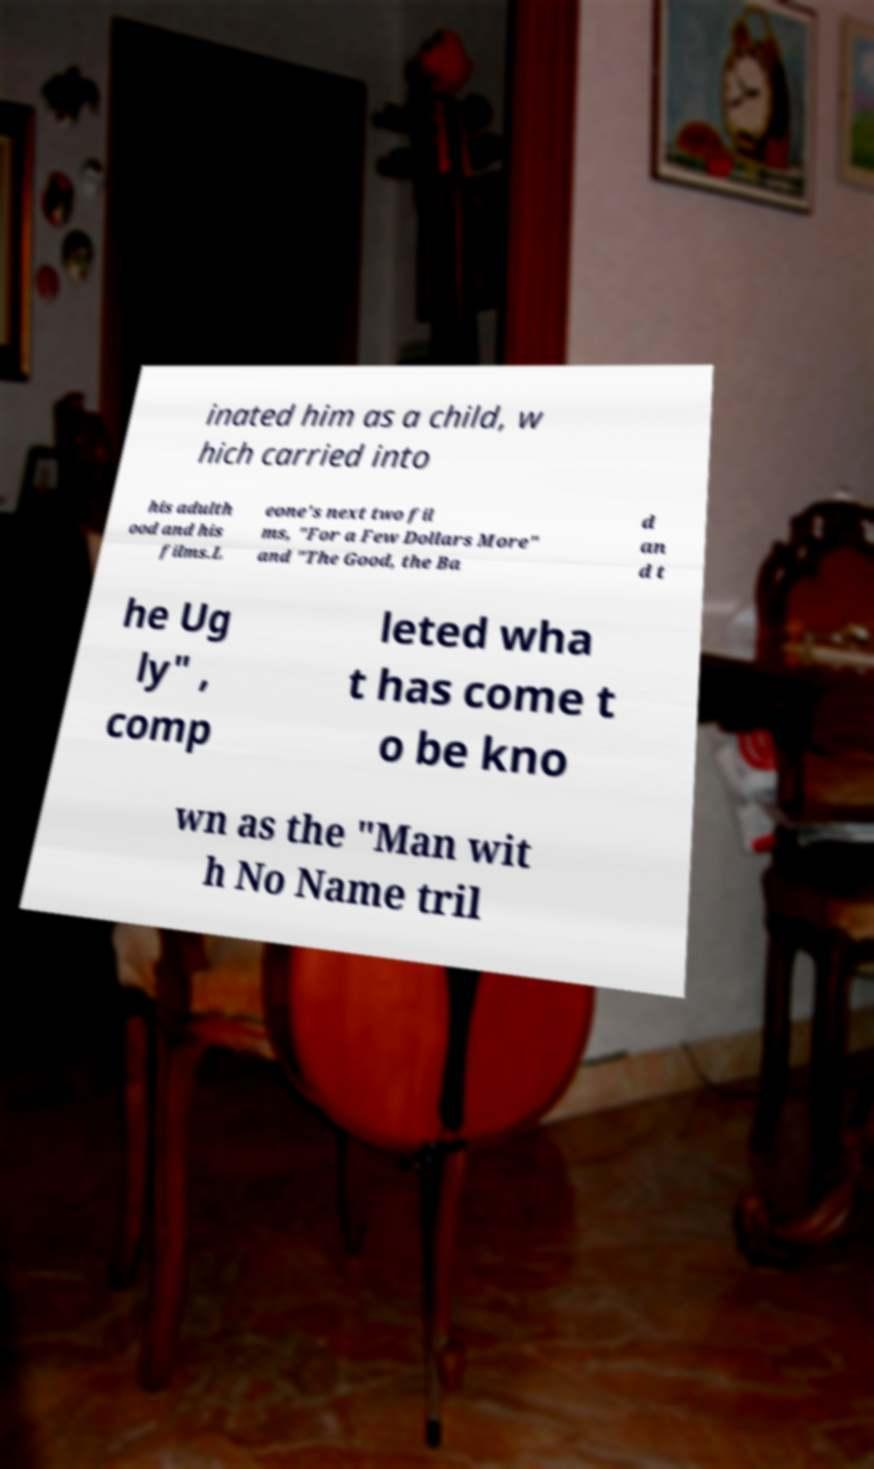What messages or text are displayed in this image? I need them in a readable, typed format. inated him as a child, w hich carried into his adulth ood and his films.L eone's next two fil ms, "For a Few Dollars More" and "The Good, the Ba d an d t he Ug ly" , comp leted wha t has come t o be kno wn as the "Man wit h No Name tril 